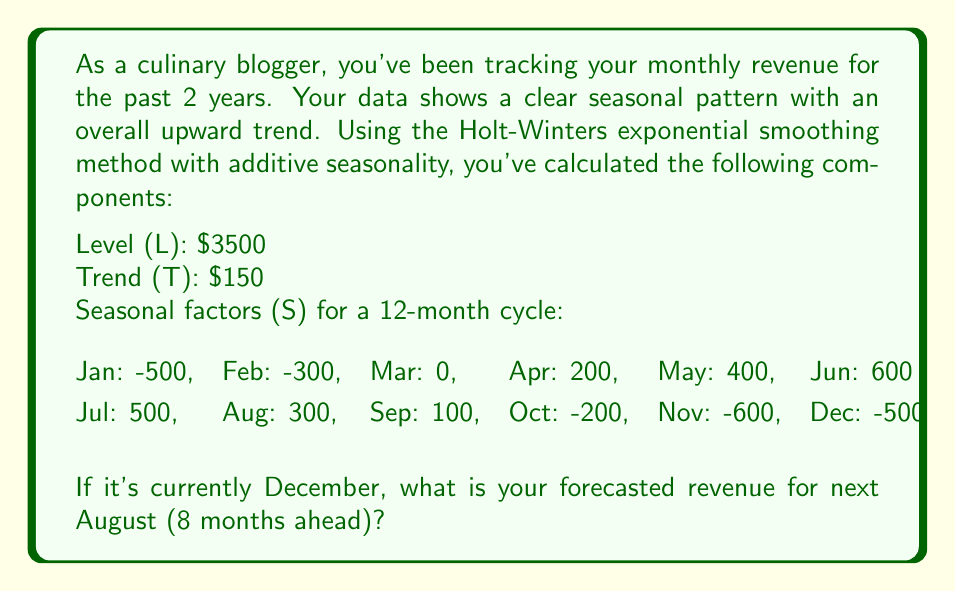Can you answer this question? To forecast future values using the Holt-Winters method with additive seasonality, we use the following formula:

$$F_{t+h} = L_t + hT_t + S_{t+h-m}$$

Where:
$F_{t+h}$ is the forecast for $h$ periods ahead
$L_t$ is the level component
$T_t$ is the trend component
$h$ is the number of periods to forecast
$S_{t+h-m}$ is the seasonal factor for the forecasted period
$m$ is the number of periods in a seasonal cycle

Given:
$L_t = 3500$
$T_t = 150$
$h = 8$ (forecasting 8 months ahead, from December to August)
$m = 12$ (12-month seasonal cycle)
$S_{t+h-m} = S_{8} = 300$ (seasonal factor for August)

Let's plug these values into the formula:

$$F_{t+8} = 3500 + (8 * 150) + 300$$

$$F_{t+8} = 3500 + 1200 + 300$$

$$F_{t+8} = 5000$$

Therefore, the forecasted revenue for next August is $5000.
Answer: $5000 